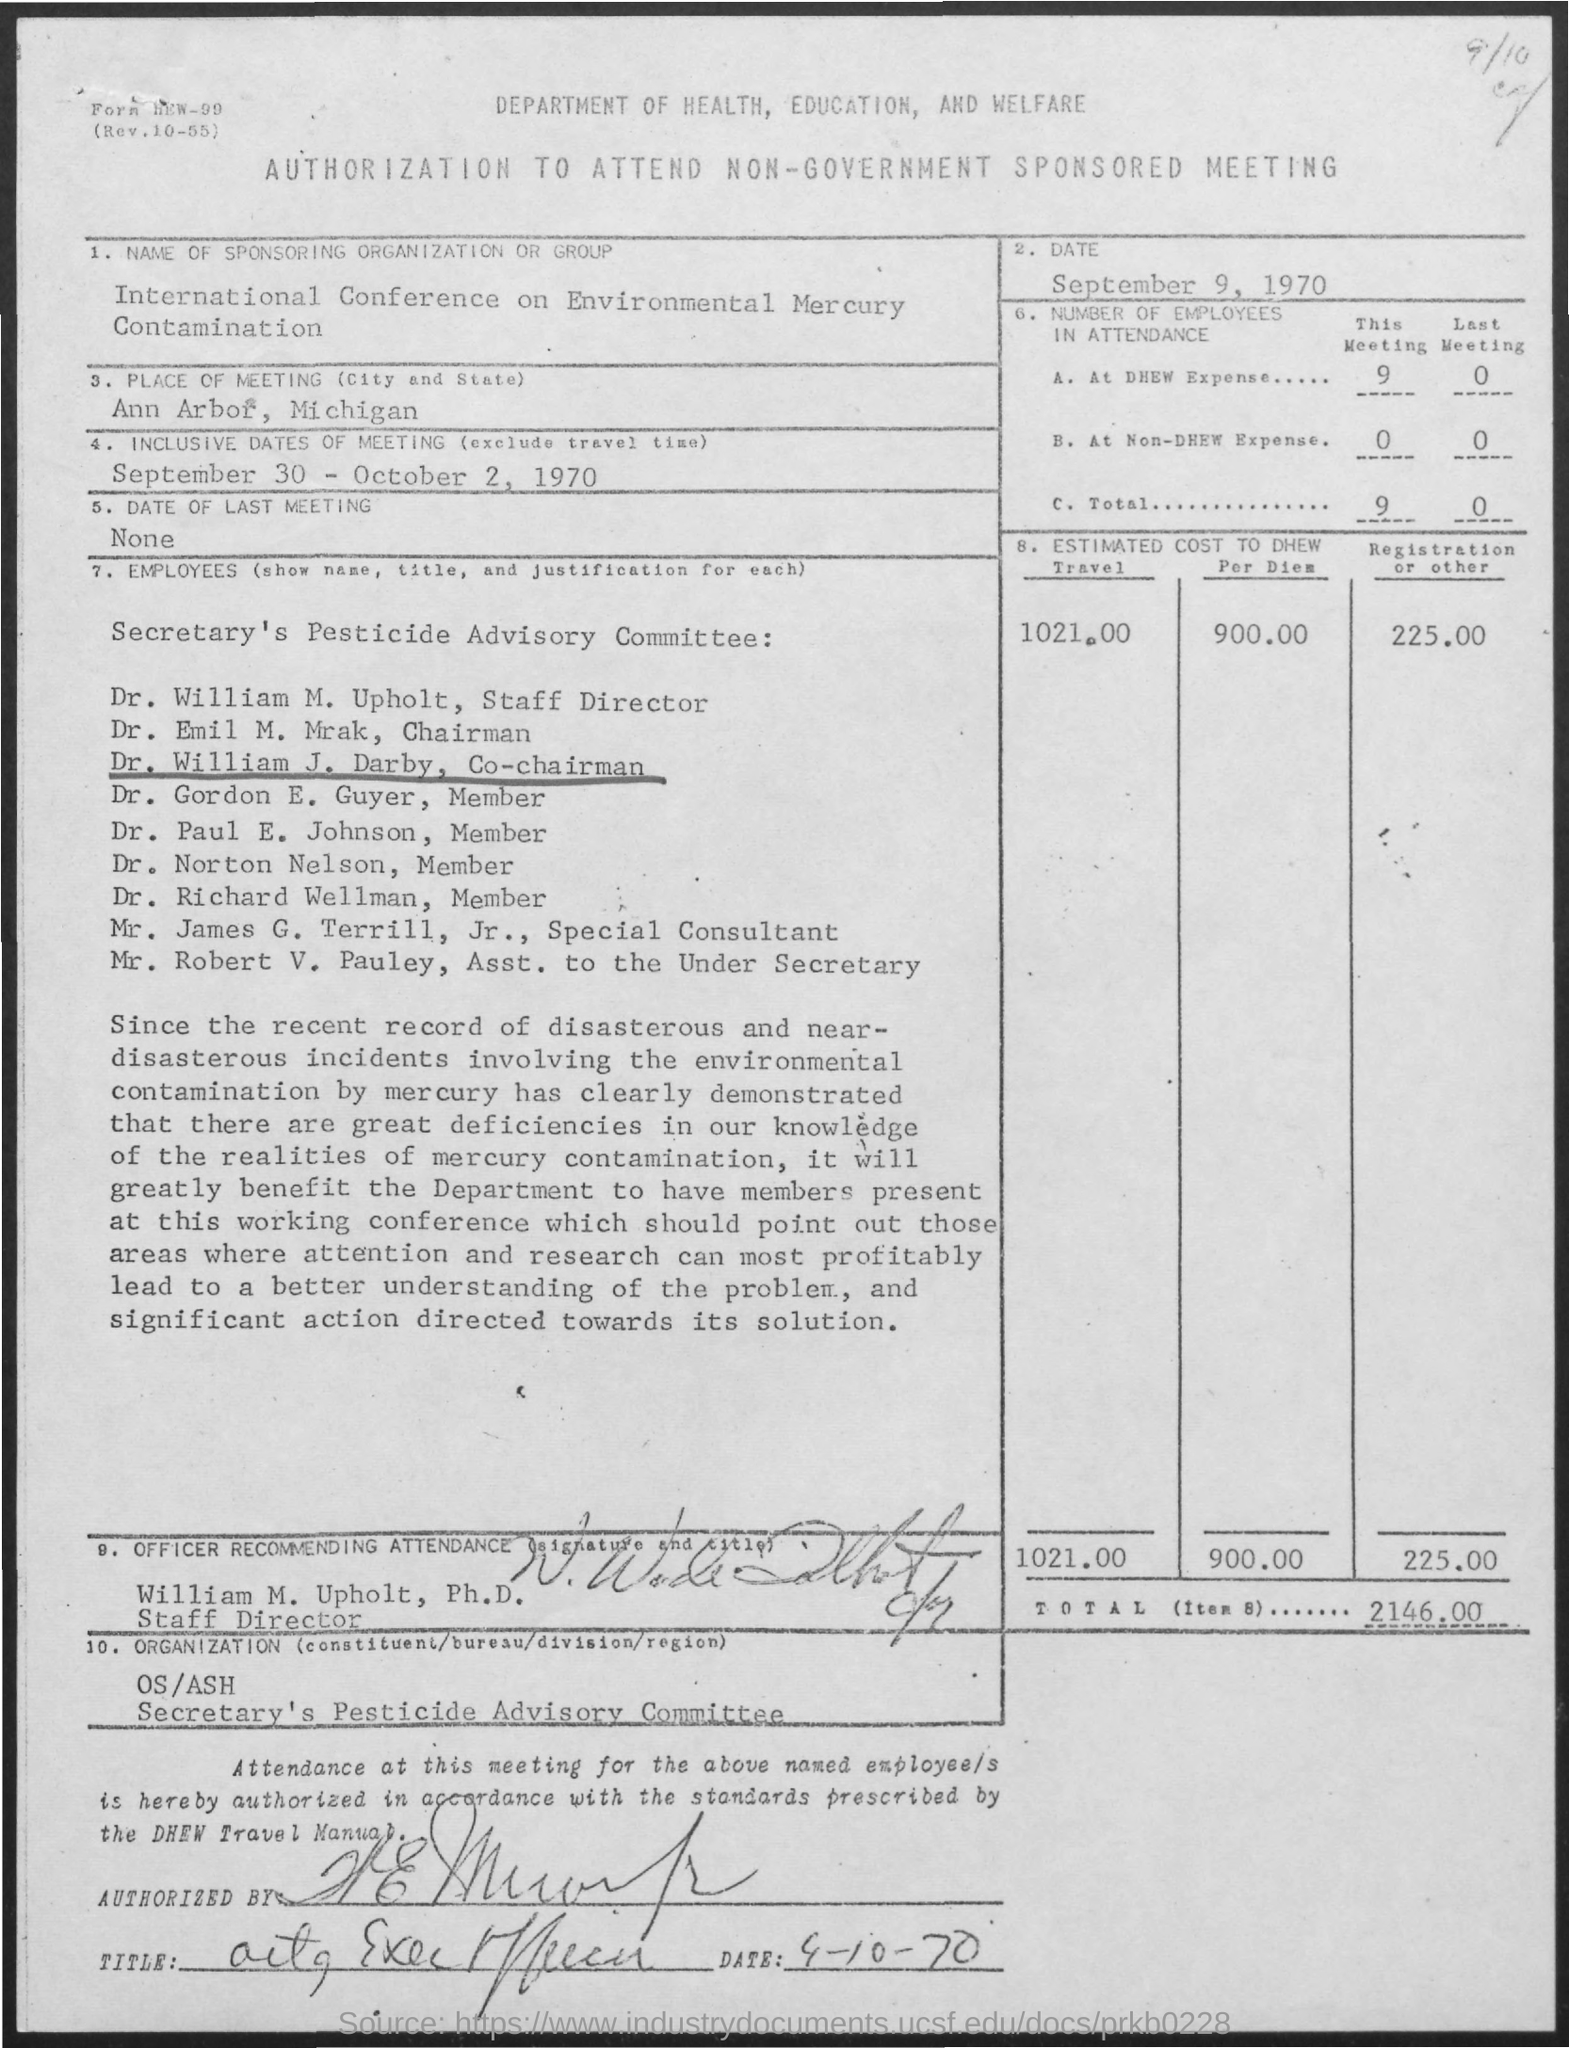What is the Date?
Your answer should be very brief. SEPTEMBER 9, 1970. What is the place of meeting?
Your response must be concise. ANN ARBOR, MICHIGAN. What are the inclusive dates of meeting?
Your answer should be very brief. September 30 - October 2, 1970. What is the date of the last meeting?
Give a very brief answer. None. What is the number of employees in attendance at DHEW Expense for this meeting?
Provide a succinct answer. 9. What is the number of employees in attendance at Non-DHEW Expense for this meeting?
Ensure brevity in your answer.  0. What is the number of employees in attendance at DHEW Expense for Last meeting?
Provide a short and direct response. 0. What is the number of employees in attendance at Non-DHEW Expense for Last meeting?
Ensure brevity in your answer.  0. What is the estimated cost to DHEW for travel?
Provide a short and direct response. 1021.00. Who is the officer recommending attendance?
Offer a very short reply. WILLIAM M. UPHOLT. 